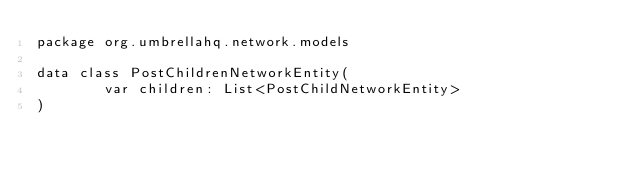Convert code to text. <code><loc_0><loc_0><loc_500><loc_500><_Kotlin_>package org.umbrellahq.network.models

data class PostChildrenNetworkEntity(
        var children: List<PostChildNetworkEntity>
)</code> 